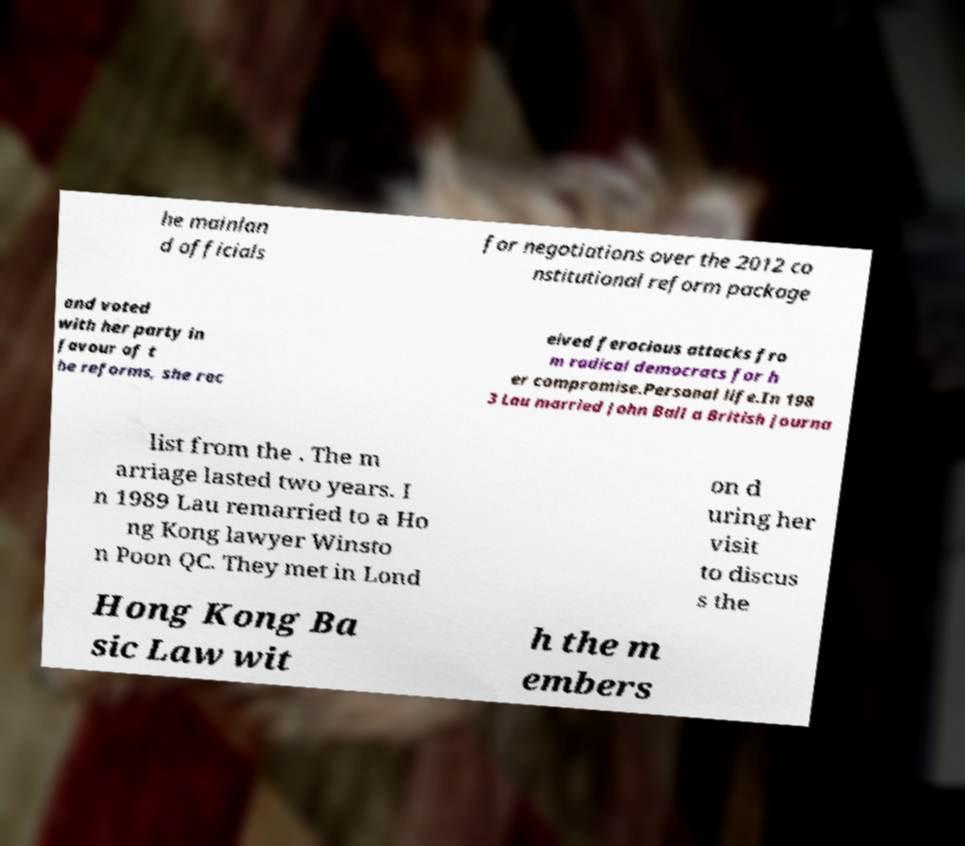I need the written content from this picture converted into text. Can you do that? he mainlan d officials for negotiations over the 2012 co nstitutional reform package and voted with her party in favour of t he reforms, she rec eived ferocious attacks fro m radical democrats for h er compromise.Personal life.In 198 3 Lau married John Ball a British journa list from the . The m arriage lasted two years. I n 1989 Lau remarried to a Ho ng Kong lawyer Winsto n Poon QC. They met in Lond on d uring her visit to discus s the Hong Kong Ba sic Law wit h the m embers 